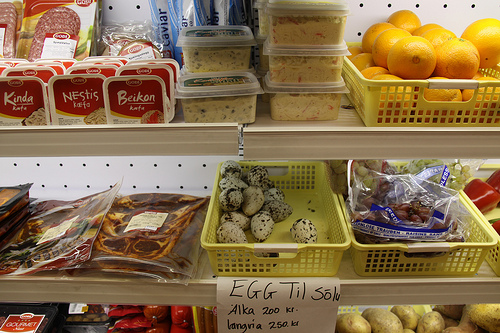<image>
Is the egg in the basket? Yes. The egg is contained within or inside the basket, showing a containment relationship. 